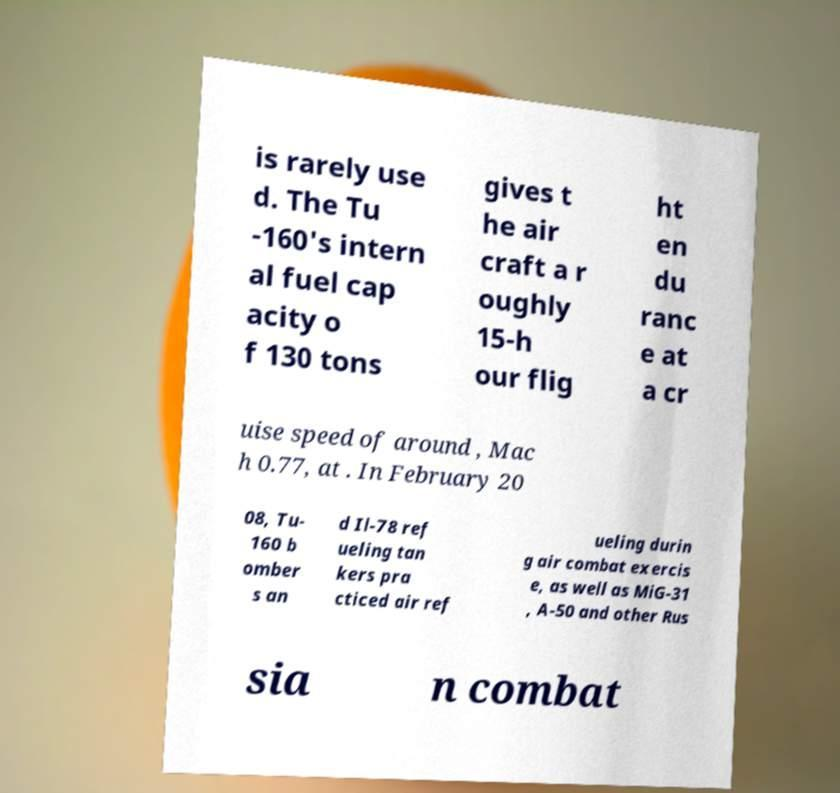Could you extract and type out the text from this image? is rarely use d. The Tu -160's intern al fuel cap acity o f 130 tons gives t he air craft a r oughly 15-h our flig ht en du ranc e at a cr uise speed of around , Mac h 0.77, at . In February 20 08, Tu- 160 b omber s an d Il-78 ref ueling tan kers pra cticed air ref ueling durin g air combat exercis e, as well as MiG-31 , A-50 and other Rus sia n combat 